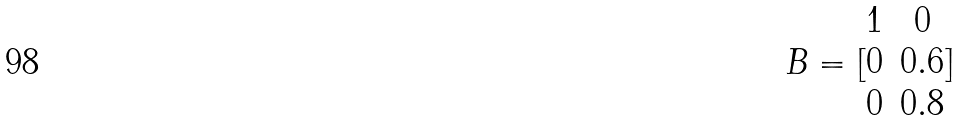Convert formula to latex. <formula><loc_0><loc_0><loc_500><loc_500>B = [ \begin{matrix} 1 & 0 \\ 0 & 0 . 6 \\ 0 & 0 . 8 \end{matrix} ]</formula> 